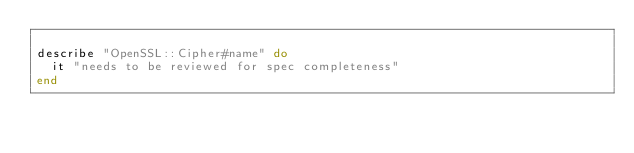Convert code to text. <code><loc_0><loc_0><loc_500><loc_500><_Ruby_>
describe "OpenSSL::Cipher#name" do
  it "needs to be reviewed for spec completeness"
end
</code> 